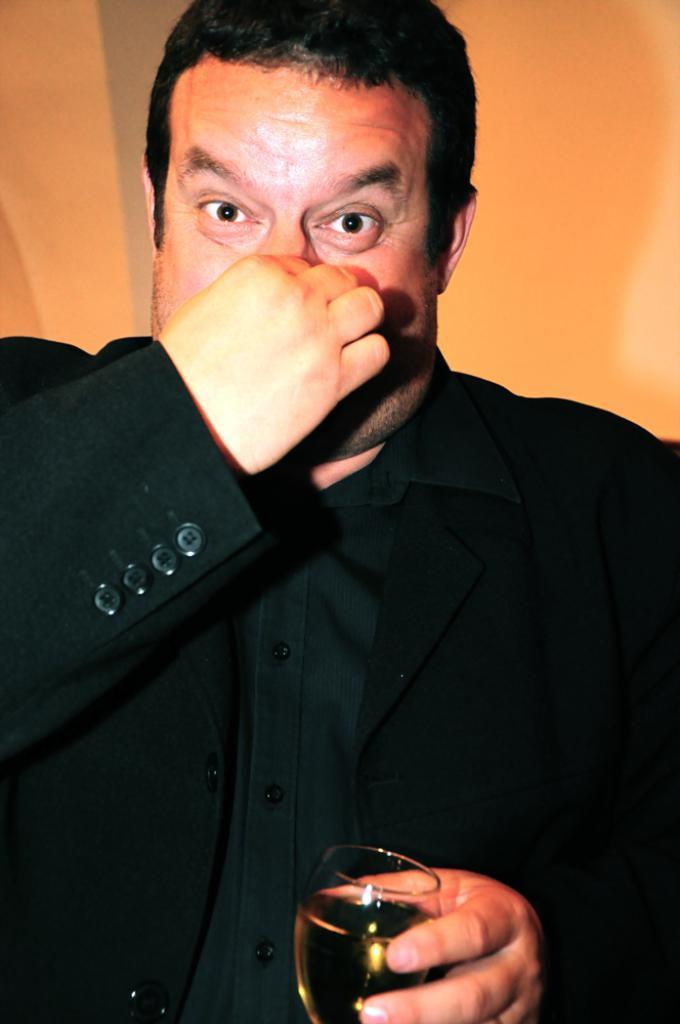What is the main subject of the image? There is a person in the image. What is the person wearing? The person is wearing a suit. What is the person holding in his hand? The person is holding a wine glass in his hand. What can be seen in the background of the image? There is a wall in the background of the image. What time of day is it in the image, specifically in the afternoon? The time of day is not mentioned or indicated in the image, so it cannot be determined if it is specifically in the afternoon. 